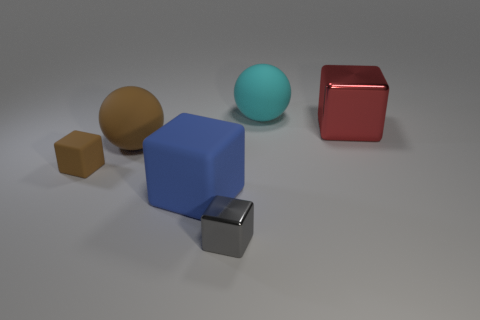Are the tiny brown cube and the tiny block to the right of the large blue matte cube made of the same material?
Provide a short and direct response. No. The cube that is behind the blue rubber object and left of the cyan matte sphere is made of what material?
Keep it short and to the point. Rubber. There is a matte thing that is in front of the tiny brown block in front of the red object; what color is it?
Provide a short and direct response. Blue. There is a sphere that is right of the large blue object; what material is it?
Give a very brief answer. Rubber. Are there fewer brown blocks than large cyan metallic balls?
Your answer should be compact. No. There is a gray object; does it have the same shape as the metallic thing that is on the right side of the tiny metallic cube?
Your answer should be very brief. Yes. There is a thing that is both in front of the red cube and right of the large blue cube; what is its shape?
Provide a short and direct response. Cube. Is the number of cyan objects in front of the small gray cube the same as the number of red blocks that are left of the cyan rubber thing?
Provide a succinct answer. Yes. Is the shape of the large blue matte object that is left of the cyan sphere the same as  the large brown rubber object?
Your answer should be compact. No. What number of blue things are either large matte balls or big matte things?
Ensure brevity in your answer.  1. 